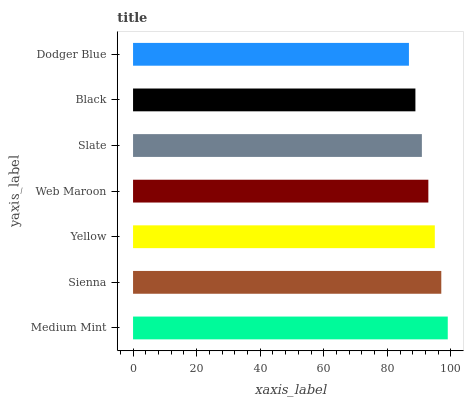Is Dodger Blue the minimum?
Answer yes or no. Yes. Is Medium Mint the maximum?
Answer yes or no. Yes. Is Sienna the minimum?
Answer yes or no. No. Is Sienna the maximum?
Answer yes or no. No. Is Medium Mint greater than Sienna?
Answer yes or no. Yes. Is Sienna less than Medium Mint?
Answer yes or no. Yes. Is Sienna greater than Medium Mint?
Answer yes or no. No. Is Medium Mint less than Sienna?
Answer yes or no. No. Is Web Maroon the high median?
Answer yes or no. Yes. Is Web Maroon the low median?
Answer yes or no. Yes. Is Medium Mint the high median?
Answer yes or no. No. Is Medium Mint the low median?
Answer yes or no. No. 